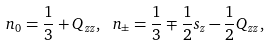<formula> <loc_0><loc_0><loc_500><loc_500>n _ { 0 } = \frac { 1 } { 3 } + Q _ { z z } , \ n _ { \pm } = \frac { 1 } { 3 } \mp \frac { 1 } { 2 } s _ { z } - \frac { 1 } { 2 } Q _ { z z } ,</formula> 